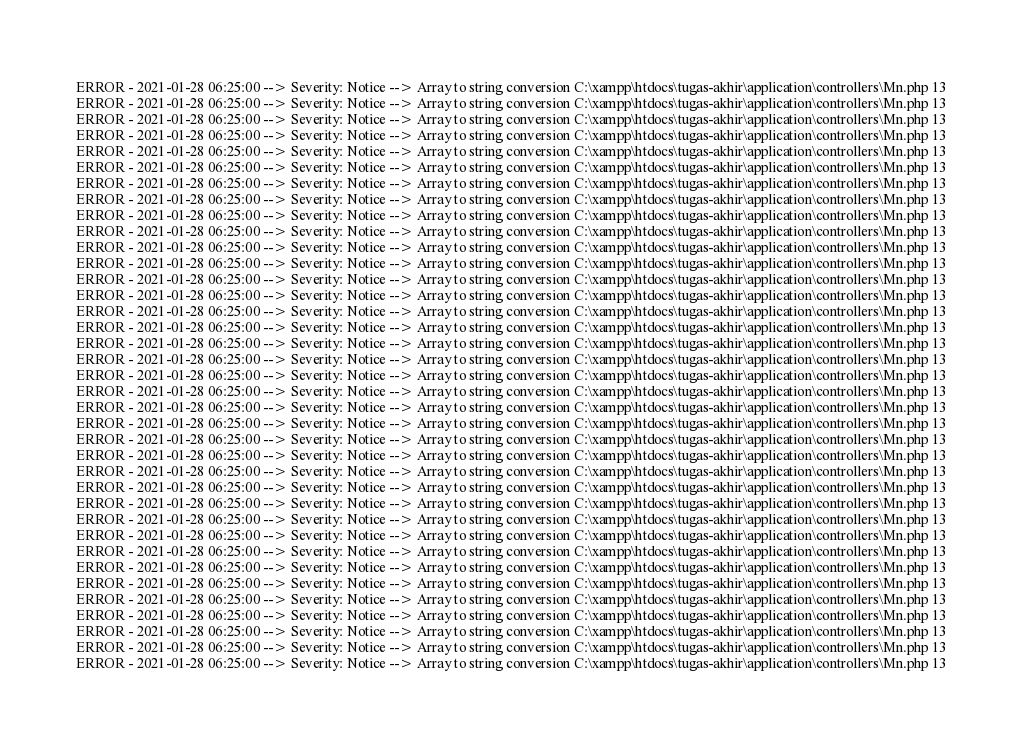Convert code to text. <code><loc_0><loc_0><loc_500><loc_500><_PHP_>ERROR - 2021-01-28 06:25:00 --> Severity: Notice --> Array to string conversion C:\xampp\htdocs\tugas-akhir\application\controllers\Mn.php 13
ERROR - 2021-01-28 06:25:00 --> Severity: Notice --> Array to string conversion C:\xampp\htdocs\tugas-akhir\application\controllers\Mn.php 13
ERROR - 2021-01-28 06:25:00 --> Severity: Notice --> Array to string conversion C:\xampp\htdocs\tugas-akhir\application\controllers\Mn.php 13
ERROR - 2021-01-28 06:25:00 --> Severity: Notice --> Array to string conversion C:\xampp\htdocs\tugas-akhir\application\controllers\Mn.php 13
ERROR - 2021-01-28 06:25:00 --> Severity: Notice --> Array to string conversion C:\xampp\htdocs\tugas-akhir\application\controllers\Mn.php 13
ERROR - 2021-01-28 06:25:00 --> Severity: Notice --> Array to string conversion C:\xampp\htdocs\tugas-akhir\application\controllers\Mn.php 13
ERROR - 2021-01-28 06:25:00 --> Severity: Notice --> Array to string conversion C:\xampp\htdocs\tugas-akhir\application\controllers\Mn.php 13
ERROR - 2021-01-28 06:25:00 --> Severity: Notice --> Array to string conversion C:\xampp\htdocs\tugas-akhir\application\controllers\Mn.php 13
ERROR - 2021-01-28 06:25:00 --> Severity: Notice --> Array to string conversion C:\xampp\htdocs\tugas-akhir\application\controllers\Mn.php 13
ERROR - 2021-01-28 06:25:00 --> Severity: Notice --> Array to string conversion C:\xampp\htdocs\tugas-akhir\application\controllers\Mn.php 13
ERROR - 2021-01-28 06:25:00 --> Severity: Notice --> Array to string conversion C:\xampp\htdocs\tugas-akhir\application\controllers\Mn.php 13
ERROR - 2021-01-28 06:25:00 --> Severity: Notice --> Array to string conversion C:\xampp\htdocs\tugas-akhir\application\controllers\Mn.php 13
ERROR - 2021-01-28 06:25:00 --> Severity: Notice --> Array to string conversion C:\xampp\htdocs\tugas-akhir\application\controllers\Mn.php 13
ERROR - 2021-01-28 06:25:00 --> Severity: Notice --> Array to string conversion C:\xampp\htdocs\tugas-akhir\application\controllers\Mn.php 13
ERROR - 2021-01-28 06:25:00 --> Severity: Notice --> Array to string conversion C:\xampp\htdocs\tugas-akhir\application\controllers\Mn.php 13
ERROR - 2021-01-28 06:25:00 --> Severity: Notice --> Array to string conversion C:\xampp\htdocs\tugas-akhir\application\controllers\Mn.php 13
ERROR - 2021-01-28 06:25:00 --> Severity: Notice --> Array to string conversion C:\xampp\htdocs\tugas-akhir\application\controllers\Mn.php 13
ERROR - 2021-01-28 06:25:00 --> Severity: Notice --> Array to string conversion C:\xampp\htdocs\tugas-akhir\application\controllers\Mn.php 13
ERROR - 2021-01-28 06:25:00 --> Severity: Notice --> Array to string conversion C:\xampp\htdocs\tugas-akhir\application\controllers\Mn.php 13
ERROR - 2021-01-28 06:25:00 --> Severity: Notice --> Array to string conversion C:\xampp\htdocs\tugas-akhir\application\controllers\Mn.php 13
ERROR - 2021-01-28 06:25:00 --> Severity: Notice --> Array to string conversion C:\xampp\htdocs\tugas-akhir\application\controllers\Mn.php 13
ERROR - 2021-01-28 06:25:00 --> Severity: Notice --> Array to string conversion C:\xampp\htdocs\tugas-akhir\application\controllers\Mn.php 13
ERROR - 2021-01-28 06:25:00 --> Severity: Notice --> Array to string conversion C:\xampp\htdocs\tugas-akhir\application\controllers\Mn.php 13
ERROR - 2021-01-28 06:25:00 --> Severity: Notice --> Array to string conversion C:\xampp\htdocs\tugas-akhir\application\controllers\Mn.php 13
ERROR - 2021-01-28 06:25:00 --> Severity: Notice --> Array to string conversion C:\xampp\htdocs\tugas-akhir\application\controllers\Mn.php 13
ERROR - 2021-01-28 06:25:00 --> Severity: Notice --> Array to string conversion C:\xampp\htdocs\tugas-akhir\application\controllers\Mn.php 13
ERROR - 2021-01-28 06:25:00 --> Severity: Notice --> Array to string conversion C:\xampp\htdocs\tugas-akhir\application\controllers\Mn.php 13
ERROR - 2021-01-28 06:25:00 --> Severity: Notice --> Array to string conversion C:\xampp\htdocs\tugas-akhir\application\controllers\Mn.php 13
ERROR - 2021-01-28 06:25:00 --> Severity: Notice --> Array to string conversion C:\xampp\htdocs\tugas-akhir\application\controllers\Mn.php 13
ERROR - 2021-01-28 06:25:00 --> Severity: Notice --> Array to string conversion C:\xampp\htdocs\tugas-akhir\application\controllers\Mn.php 13
ERROR - 2021-01-28 06:25:00 --> Severity: Notice --> Array to string conversion C:\xampp\htdocs\tugas-akhir\application\controllers\Mn.php 13
ERROR - 2021-01-28 06:25:00 --> Severity: Notice --> Array to string conversion C:\xampp\htdocs\tugas-akhir\application\controllers\Mn.php 13
ERROR - 2021-01-28 06:25:00 --> Severity: Notice --> Array to string conversion C:\xampp\htdocs\tugas-akhir\application\controllers\Mn.php 13
ERROR - 2021-01-28 06:25:00 --> Severity: Notice --> Array to string conversion C:\xampp\htdocs\tugas-akhir\application\controllers\Mn.php 13
ERROR - 2021-01-28 06:25:00 --> Severity: Notice --> Array to string conversion C:\xampp\htdocs\tugas-akhir\application\controllers\Mn.php 13
ERROR - 2021-01-28 06:25:00 --> Severity: Notice --> Array to string conversion C:\xampp\htdocs\tugas-akhir\application\controllers\Mn.php 13
ERROR - 2021-01-28 06:25:00 --> Severity: Notice --> Array to string conversion C:\xampp\htdocs\tugas-akhir\application\controllers\Mn.php 13</code> 